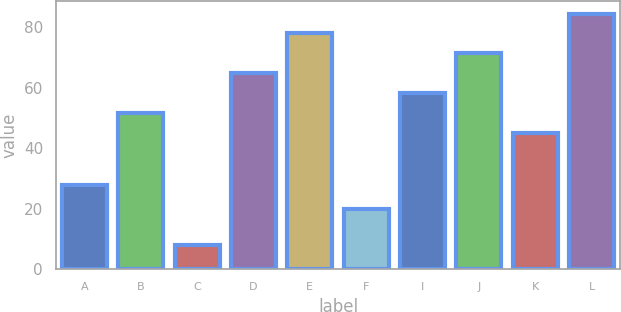Convert chart. <chart><loc_0><loc_0><loc_500><loc_500><bar_chart><fcel>A<fcel>B<fcel>C<fcel>D<fcel>E<fcel>F<fcel>I<fcel>J<fcel>K<fcel>L<nl><fcel>28<fcel>51.6<fcel>8<fcel>64.8<fcel>78<fcel>20<fcel>58.2<fcel>71.4<fcel>45<fcel>84.6<nl></chart> 